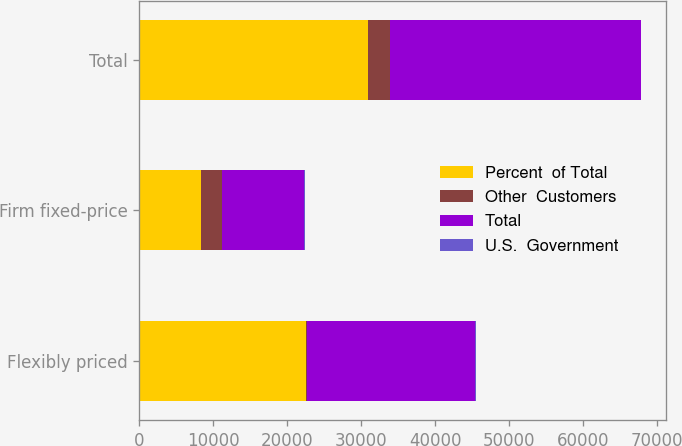Convert chart to OTSL. <chart><loc_0><loc_0><loc_500><loc_500><stacked_bar_chart><ecel><fcel>Flexibly priced<fcel>Firm fixed-price<fcel>Total<nl><fcel>Percent  of Total<fcel>22534<fcel>8358<fcel>30892<nl><fcel>Other  Customers<fcel>184<fcel>2811<fcel>2995<nl><fcel>Total<fcel>22718<fcel>11169<fcel>33887<nl><fcel>U.S.  Government<fcel>67<fcel>33<fcel>100<nl></chart> 